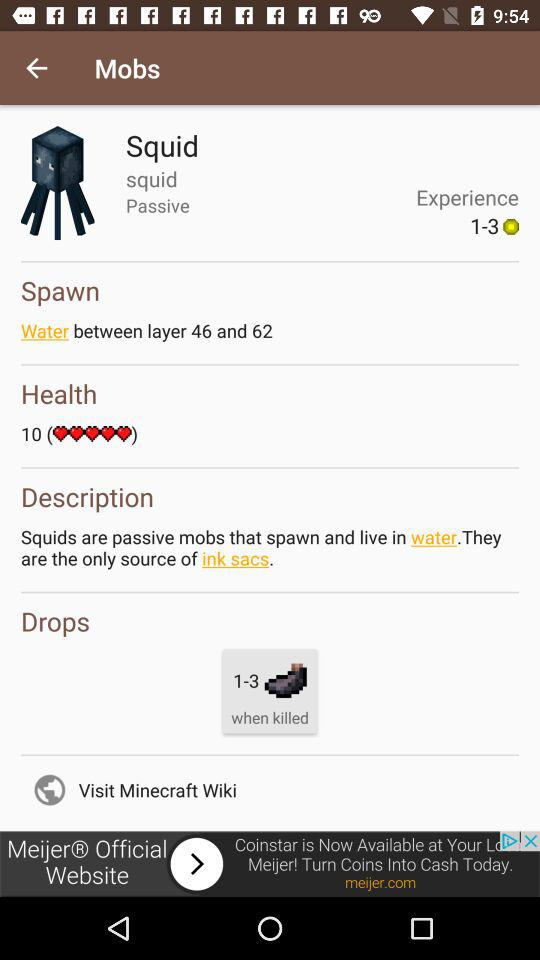How many drops does a squid have when killed?
Answer the question using a single word or phrase. 1-3 